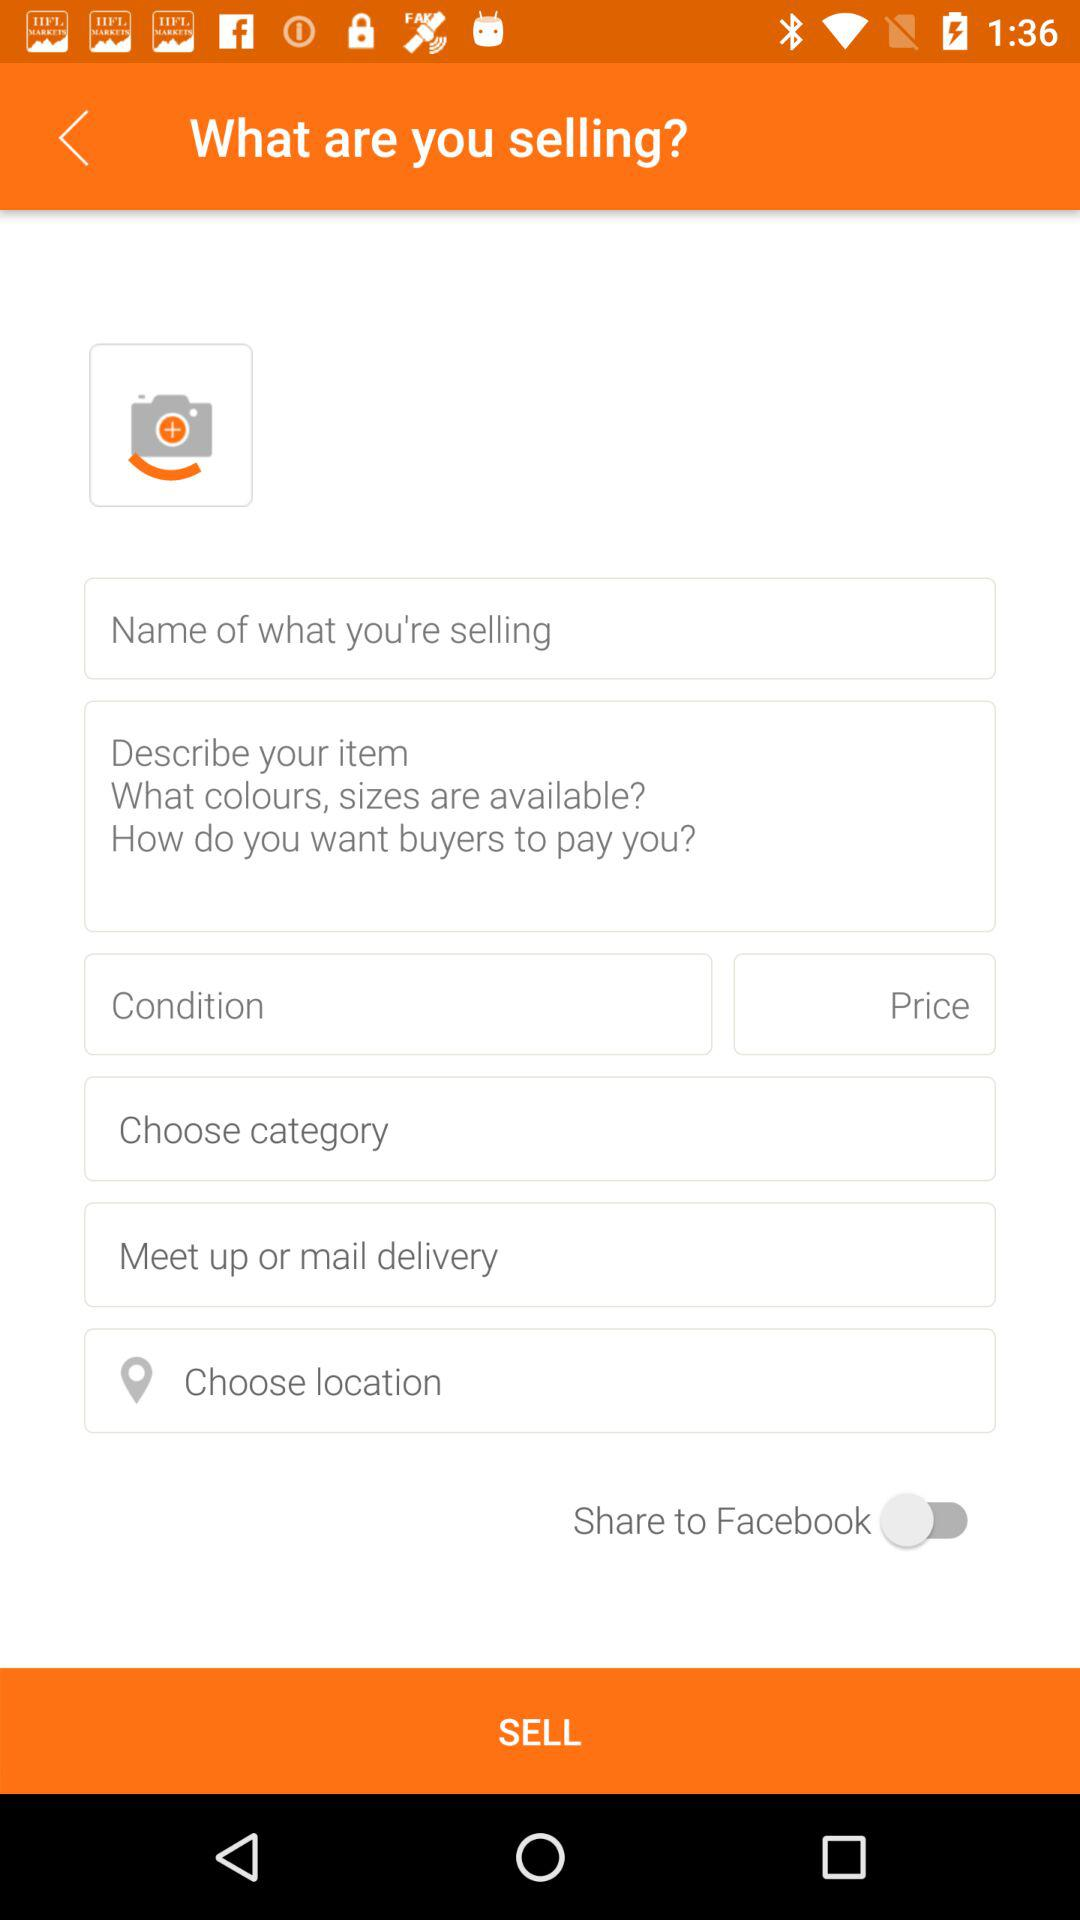What is the status of "Share to Facebook"? The status is "off". 